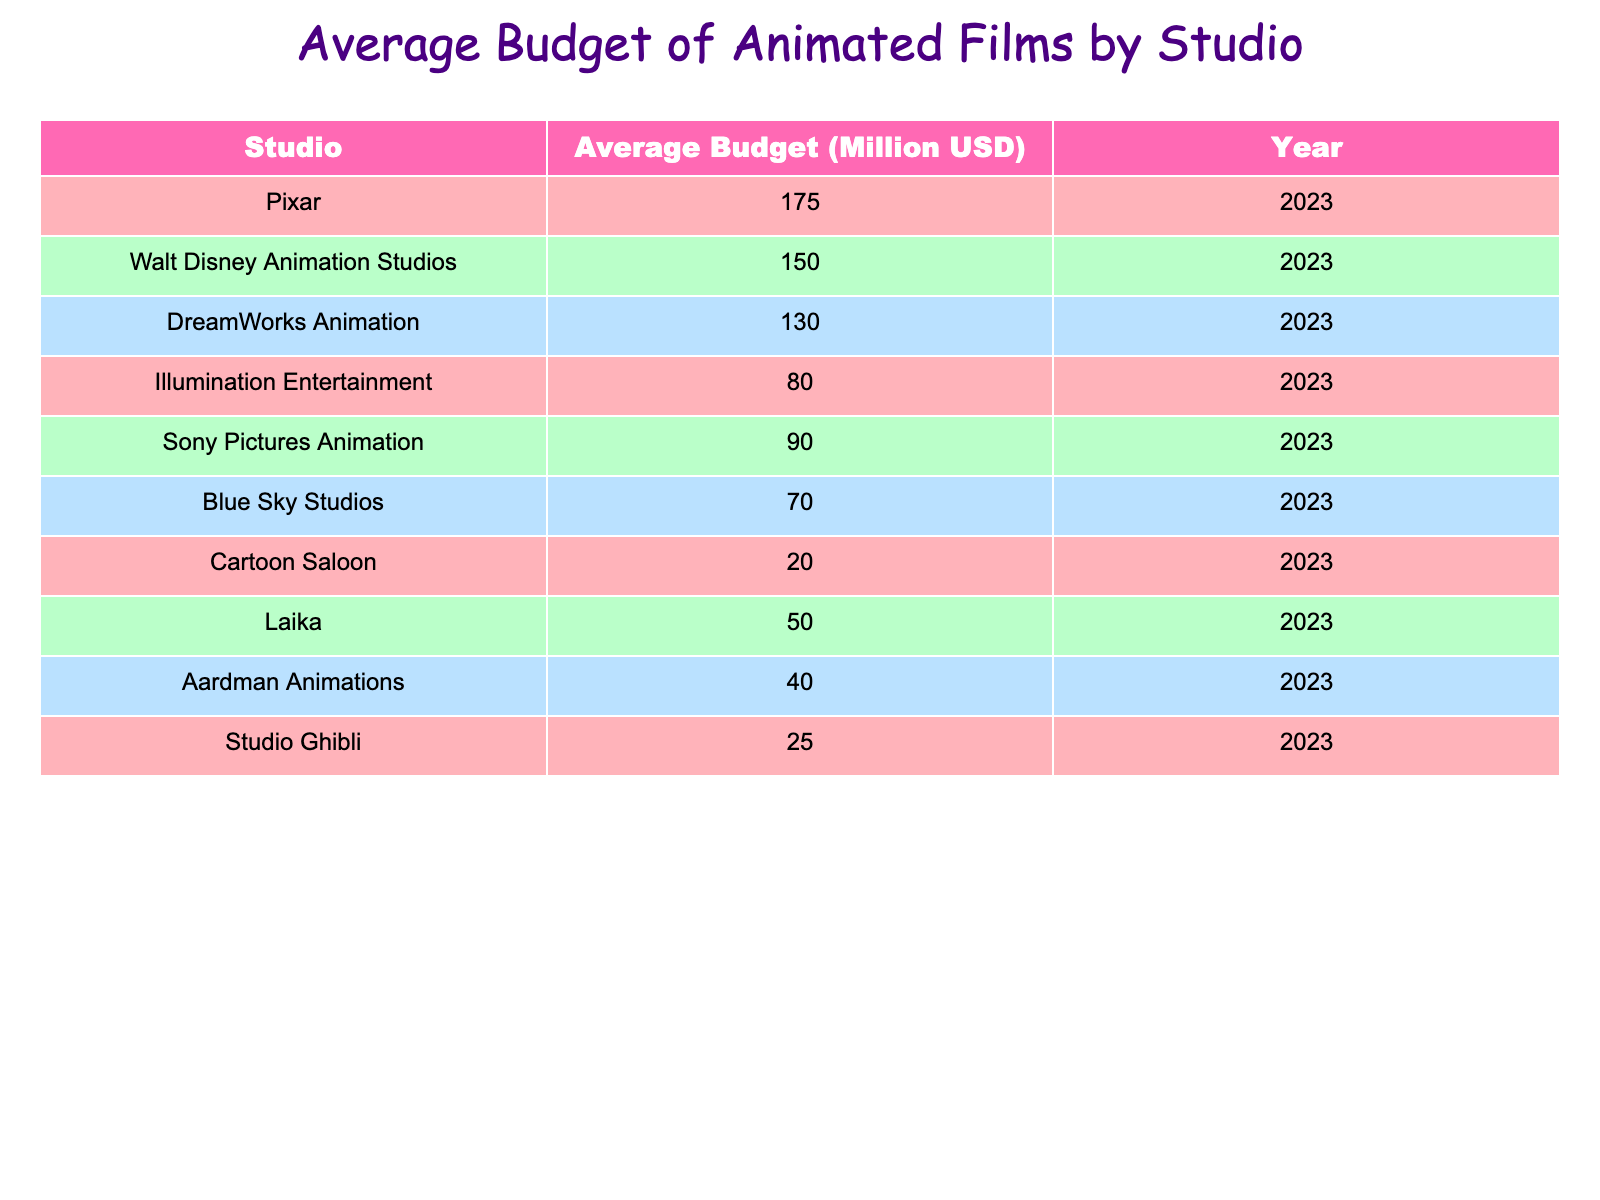What is the average budget of Pixar films? The table shows that the average budget for Pixar is 175 million USD. This value is located in the "Average Budget (Million USD)" column corresponding to the "Pixar" row.
Answer: 175 million USD Which studio has the lowest average budget? By examining the "Average Budget (Million USD)" column, the lowest value is 20 million USD, which corresponds to "Cartoon Saloon." Therefore, Cartoon Saloon is the studio with the lowest average budget.
Answer: Cartoon Saloon Calculate the average budget of all studios listed. To find the average budget, sum all the average budgets: 175 + 150 + 130 + 80 + 90 + 70 + 20 + 50 + 40 + 25 =  1010. Then, divide this by the number of studios (10), resulting in an average budget of 1010/10 = 101 million USD.
Answer: 101 million USD Is the average budget of DreamWorks Animation greater than that of Illumination Entertainment? The average budget for DreamWorks Animation is 130 million USD and for Illumination Entertainment, it is 80 million USD. Since 130 is greater than 80, the statement is true.
Answer: Yes How much higher is the average budget of Walt Disney Animation Studios compared to Aardman Animations? The average budget for Walt Disney Animation Studios is 150 million USD, and for Aardman Animations, it is 40 million USD. To find the difference, subtract 40 from 150, which equals 110 million USD.
Answer: 110 million USD What percentage of the average budget does Studio Ghibli represent compared to Pixar? The average budget of Studio Ghibli is 25 million USD and for Pixar, it is 175 million USD. To find the percentage, (25/175) * 100 = 14.29%. Therefore, Studio Ghibli's budget represents approximately 14.29% of Pixar's budget.
Answer: 14.29% Are there more studios with an average budget above 100 million USD or below 100 million USD? By examining the budgets, the studios with an average budget above 100 million USD are Pixar, Walt Disney Animation Studios, and DreamWorks Animation (3 studios). The studios below 100 million USD are Illumination Entertainment, Sony Pictures Animation, Blue Sky Studios, Cartoon Saloon, Laika, Aardman Animations, and Studio Ghibli (7 studios). Thus, there are more studios with an average budget below 100 million USD.
Answer: Below 100 million USD How many studios have an average budget below 50 million USD? From the "Average Budget (Million USD)" column, we observe that Cartoon Saloon (20 million), Laika (50 million), and Aardman Animations (40 million) are below 50 million USD. Therefore, there are three studios with an average budget below 50 million USD.
Answer: 2 studios 